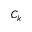<formula> <loc_0><loc_0><loc_500><loc_500>C _ { k }</formula> 